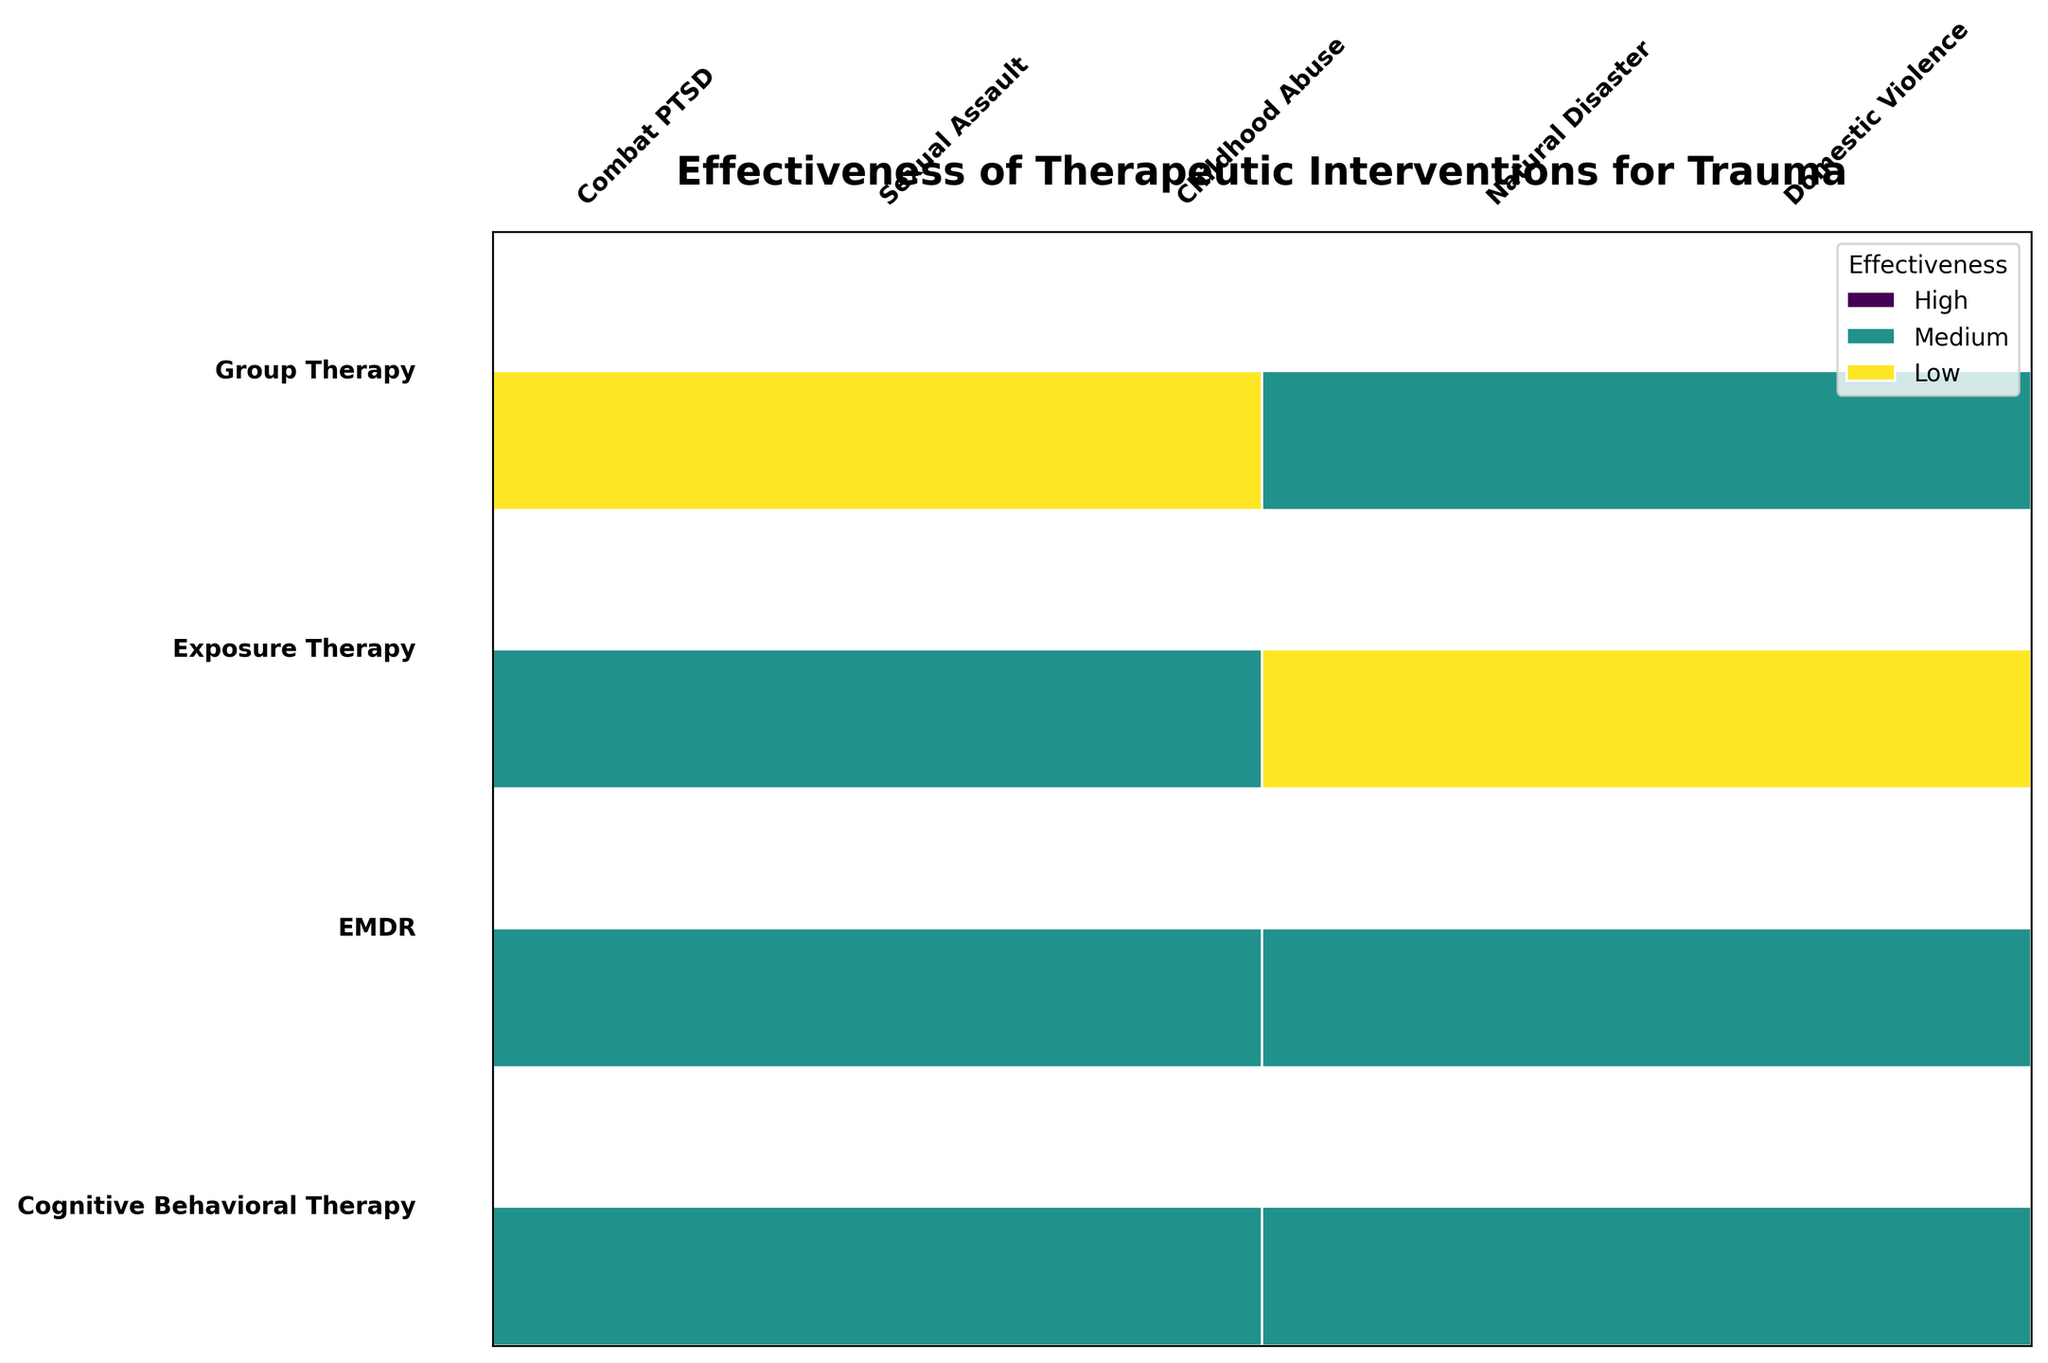What is the title of the mosaic plot? The title is typically displayed at the top of the plot. Reading directly from this area will provide the answer.
Answer: Effectiveness of Therapeutic Interventions for Trauma How many therapeutic interventions are compared in the plot? Count the distinct therapeutic interventions listed along the vertical axis.
Answer: Four Which age groups are analyzed in this study? Look for any groupings by age in the segments and categories listed in the plot.
Answer: 18-30, 31-50 Which gender has a high effectiveness for EMDR in dealing with childhood abuse trauma? Identify the segment corresponding to EMDR and childhood abuse trauma, then note the gender and effectiveness levels.
Answer: Female In terms of combat PTSD, does Cognitive Behavioral Therapy have a higher effectiveness in the 18-30 age group or the 31-50 age group? Examine the segments for Cognitive Behavioral Therapy under combat PTSD and compare the effectiveness levels for the two age groups.
Answer: 18-30 Which therapeutic intervention is shown to be most effective for natural disaster-related trauma in the 18-30 age group? Locate the segments related to natural disaster trauma for the 18-30 age group and note which intervention corresponds to high effectiveness.
Answer: Group Therapy Are there any instances where the same therapeutic intervention has different effectiveness outcomes depending on the type of trauma? Compare the effectiveness levels of the same therapeutic intervention across different trauma types within the plot.
Answer: Yes, Cognitive Behavioral Therapy and Exposure Therapy show different outcomes Which gender has a lower effectiveness rating for Exposure Therapy dealing with domestic violence trauma? Find the segments for Exposure Therapy relating to domestic violence trauma and check the effectiveness rating for each gender.
Answer: Male What is the effectiveness of Group Therapy for sexual assault trauma in the 18-30 age group? Navigate to the segments of Group Therapy for sexual assault trauma targeting the 18-30 age group and identify the effectiveness level.
Answer: Medium 